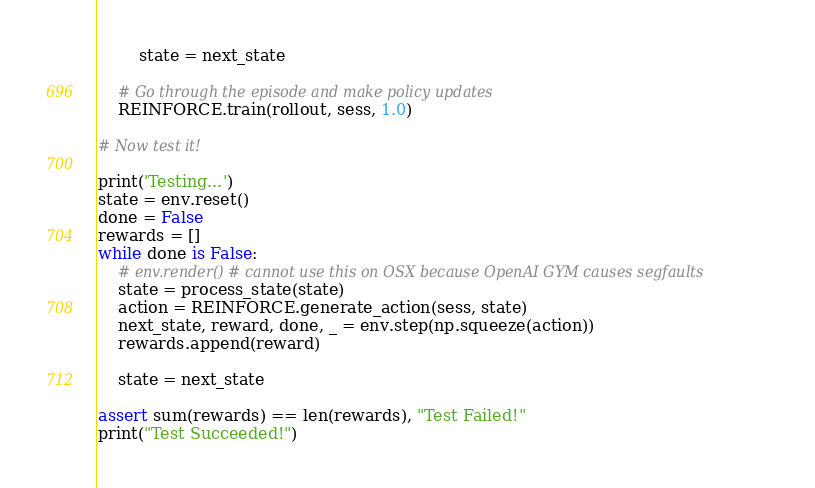Convert code to text. <code><loc_0><loc_0><loc_500><loc_500><_Python_>
        state = next_state

    # Go through the episode and make policy updates
    REINFORCE.train(rollout, sess, 1.0)

# Now test it!

print('Testing...')
state = env.reset()
done = False
rewards = []
while done is False:
    # env.render() # cannot use this on OSX because OpenAI GYM causes segfaults
    state = process_state(state)
    action = REINFORCE.generate_action(sess, state)
    next_state, reward, done, _ = env.step(np.squeeze(action))
    rewards.append(reward)

    state = next_state

assert sum(rewards) == len(rewards), "Test Failed!"
print("Test Succeeded!")
</code> 